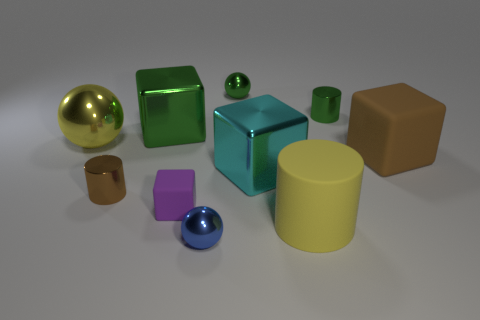There is a tiny shiny thing that is right of the big yellow matte cylinder; is its color the same as the shiny cube left of the blue metallic sphere?
Give a very brief answer. Yes. What material is the object that is on the right side of the yellow matte thing and behind the large green object?
Your answer should be very brief. Metal. What color is the large matte cube?
Keep it short and to the point. Brown. What number of other objects are there of the same shape as the brown matte thing?
Provide a short and direct response. 3. Are there the same number of small matte objects that are on the right side of the blue sphere and metal cylinders that are left of the large green cube?
Give a very brief answer. No. What material is the small block?
Provide a succinct answer. Rubber. There is a yellow cylinder in front of the large green cube; what material is it?
Your answer should be very brief. Rubber. Are there more things in front of the big yellow cylinder than tiny green rubber balls?
Your answer should be very brief. Yes. Is there a blue ball that is behind the big shiny block that is to the right of the blue metal thing in front of the small green metallic cylinder?
Your response must be concise. No. Are there any small shiny things in front of the brown matte thing?
Your answer should be compact. Yes. 